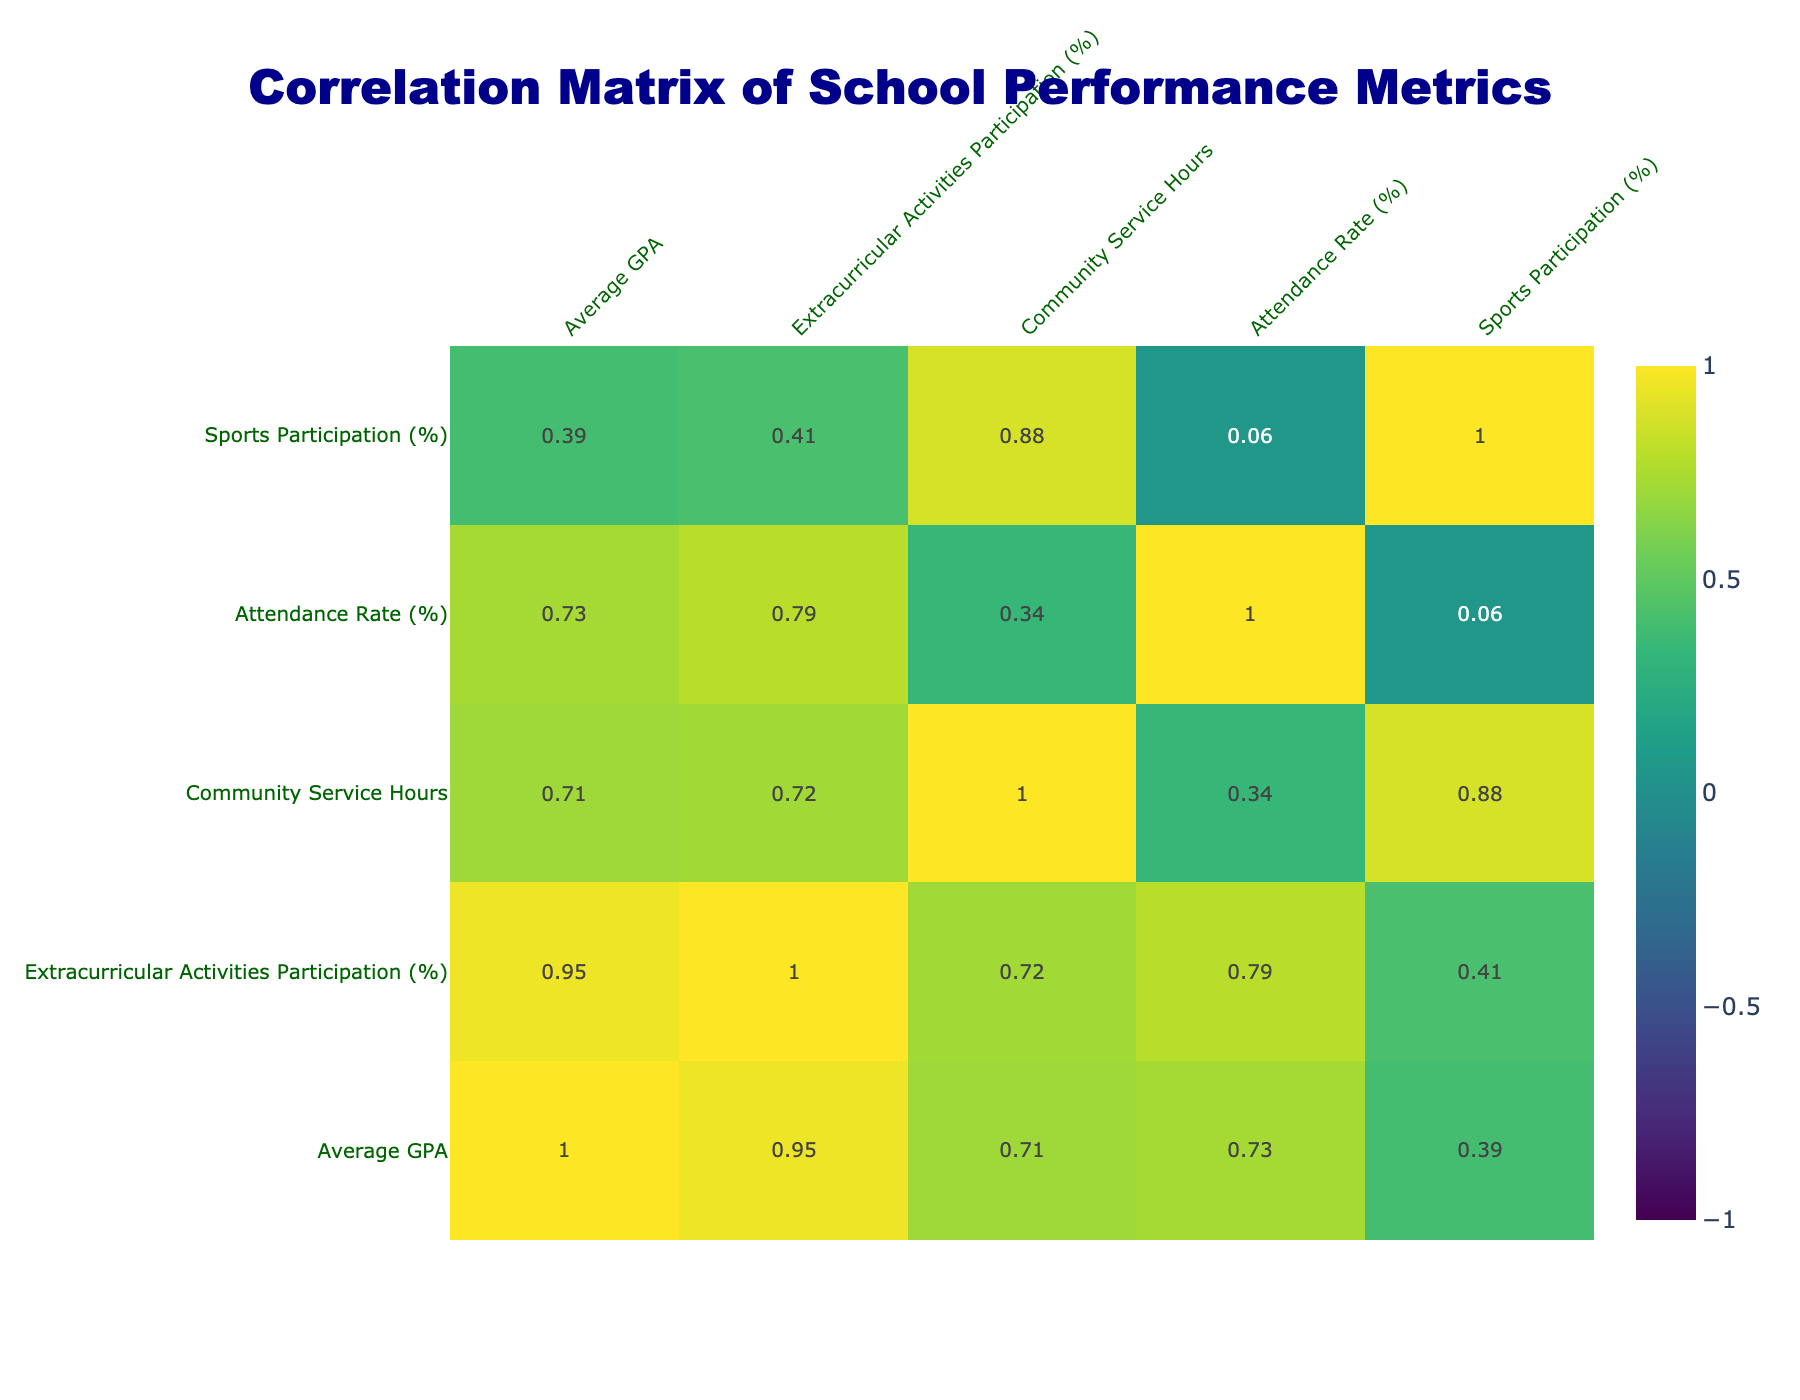What is the average GPA of Joplin High School? Looking at the table, the Average GPA for Joplin High School is listed as 3.2.
Answer: 3.2 Which school has the highest percentage of extracurricular activities participation? Joplin Community College shows the highest percentage at 90%, compared to other schools listed.
Answer: 90% Is there a correlation between the attendance rate and the average GPA across the schools? The correlation can be deduced from the table; comparing both columns shows a positive relationship, indicating that higher attendance rates are associated with higher GPAs.
Answer: Yes What is the total community service hours for schools with sports participation above 30%? We identify the schools with sports participation above 30%: Joplin Community College (40), Joplin Academy (35), and Joplin High School (30). Adding their community service hours gives 40 + 35 + 30 = 105.
Answer: 105 How much higher is the attendance rate of North Elementary School compared to East Middle School? The attendance rate for North Elementary School is 97% while for East Middle School, it is 91%. The difference can be calculated as 97 - 91 = 6%.
Answer: 6% Does Joplin Academy have a lower GPA than West High School? By checking the Average GPA, Joplin Academy has a GPA of 3.7 while West High School has 3.1. Therefore, Joplin Academy has a higher GPA than West High School.
Answer: No What is the average extracurricular activities participation percentage among all listed schools? Adding the percentages of all schools: (75 + 60 + 80 + 90 + 55 + 85 + 70 + 78) and dividing by the number of schools (8) gives (75 + 60 + 80 + 90 + 55 + 85 + 70 + 78) =  648; average = 648/8 = 81.
Answer: 81 Which school has the lowest attendance rate, and what is it? The attendance rate of East Middle School at 91% is identifiable as the lowest when compared to the other schools' rates listed.
Answer: 91 How many more community service hours does Joplin Community College have than South Middle School? Joplin Community College has 40 community service hours and South Middle School has 25 hours. Subtracting gives 40 - 25 = 15.
Answer: 15 